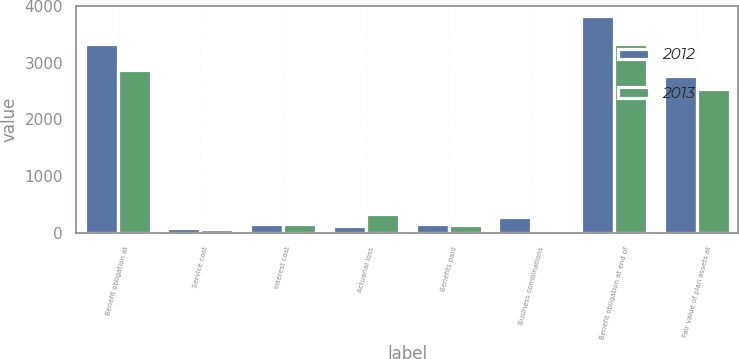Convert chart. <chart><loc_0><loc_0><loc_500><loc_500><stacked_bar_chart><ecel><fcel>Benefit obligation at<fcel>Service cost<fcel>Interest cost<fcel>Actuarial loss<fcel>Benefits paid<fcel>Business combinations<fcel>Benefit obligation at end of<fcel>Fair value of plan assets at<nl><fcel>2012<fcel>3328.3<fcel>81.8<fcel>150.1<fcel>114.3<fcel>147.8<fcel>284.4<fcel>3817.5<fcel>2766.6<nl><fcel>2013<fcel>2881.4<fcel>68.7<fcel>149.2<fcel>337.5<fcel>138.8<fcel>25<fcel>3328.3<fcel>2543.9<nl></chart> 